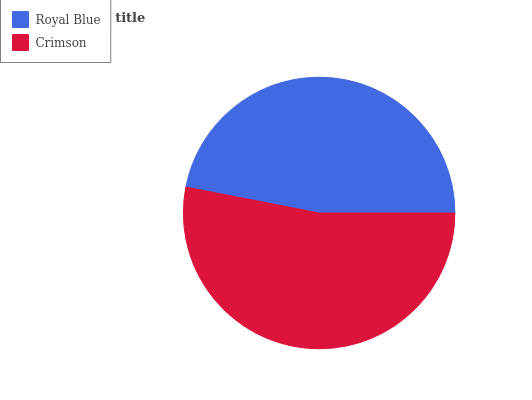Is Royal Blue the minimum?
Answer yes or no. Yes. Is Crimson the maximum?
Answer yes or no. Yes. Is Crimson the minimum?
Answer yes or no. No. Is Crimson greater than Royal Blue?
Answer yes or no. Yes. Is Royal Blue less than Crimson?
Answer yes or no. Yes. Is Royal Blue greater than Crimson?
Answer yes or no. No. Is Crimson less than Royal Blue?
Answer yes or no. No. Is Crimson the high median?
Answer yes or no. Yes. Is Royal Blue the low median?
Answer yes or no. Yes. Is Royal Blue the high median?
Answer yes or no. No. Is Crimson the low median?
Answer yes or no. No. 